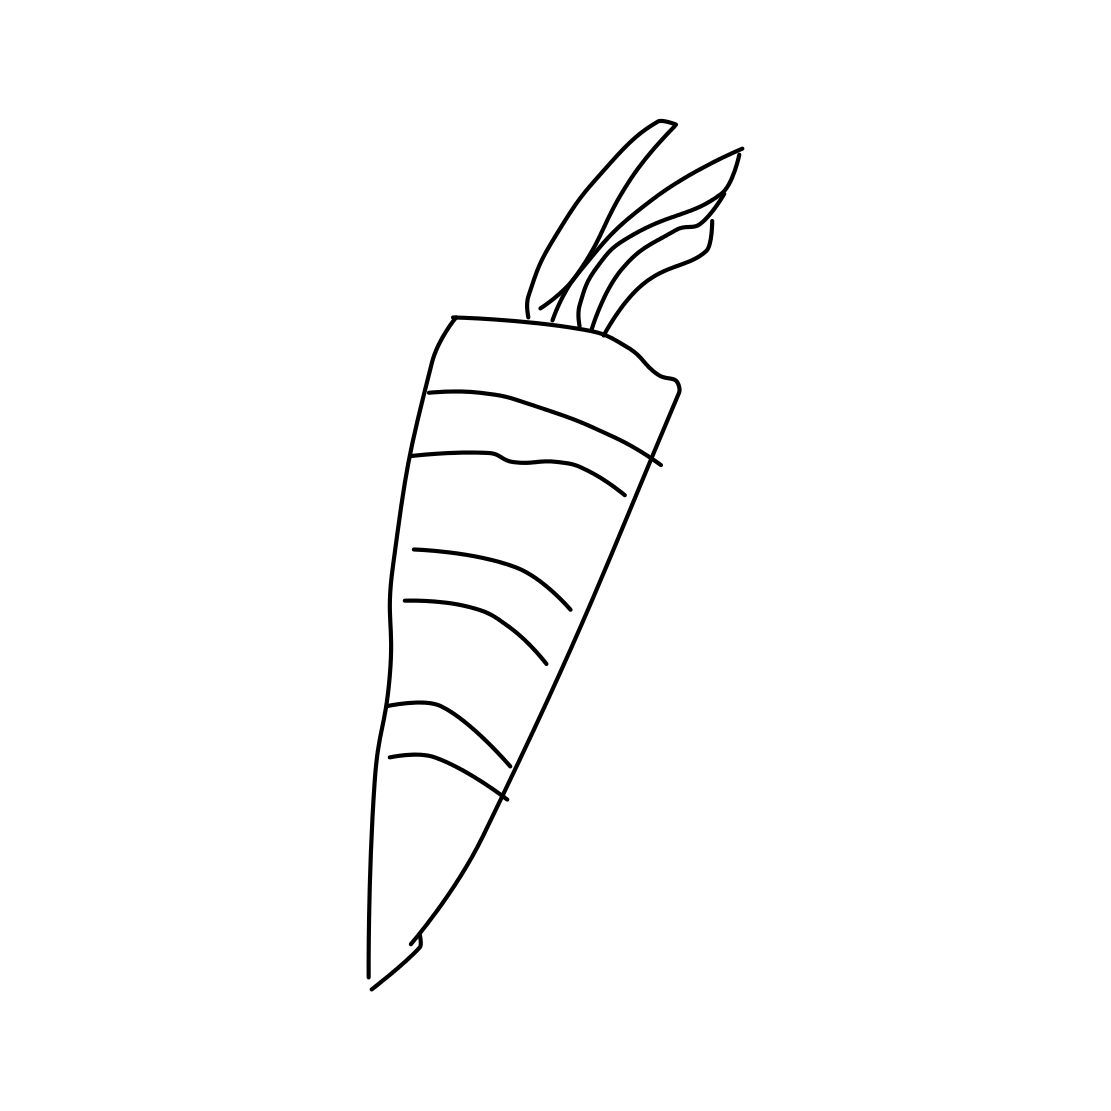What part of the carrot is mainly shown in the image? The image primarily shows the root part of the carrot, which is the edible section commonly consumed. This part typically grows underground and is responsible for storing nutrients. 